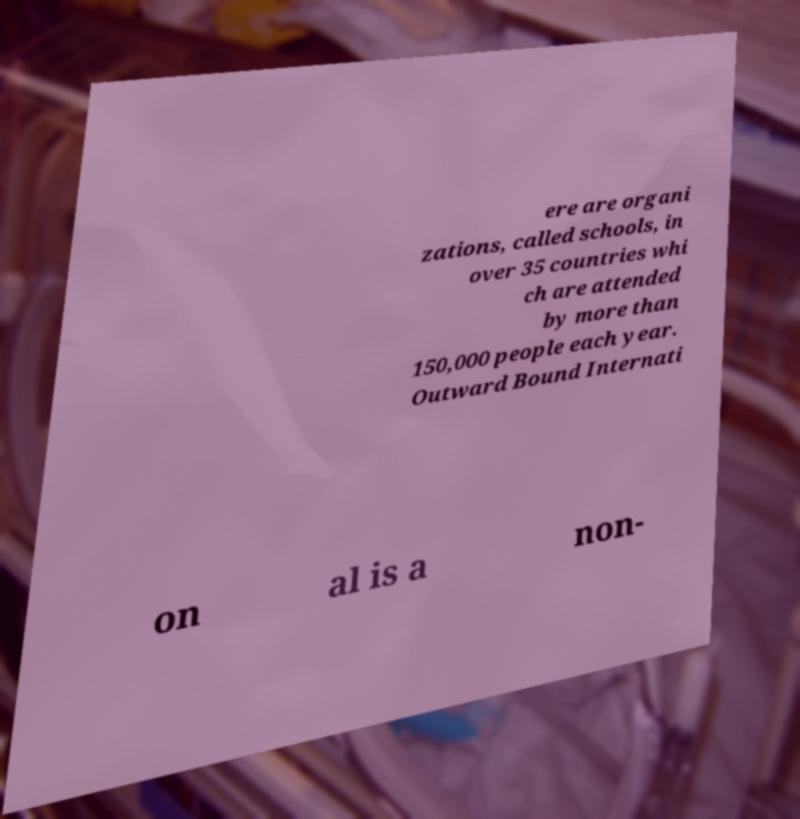Could you extract and type out the text from this image? ere are organi zations, called schools, in over 35 countries whi ch are attended by more than 150,000 people each year. Outward Bound Internati on al is a non- 